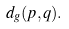Convert formula to latex. <formula><loc_0><loc_0><loc_500><loc_500>d _ { g } ( p , q ) .</formula> 